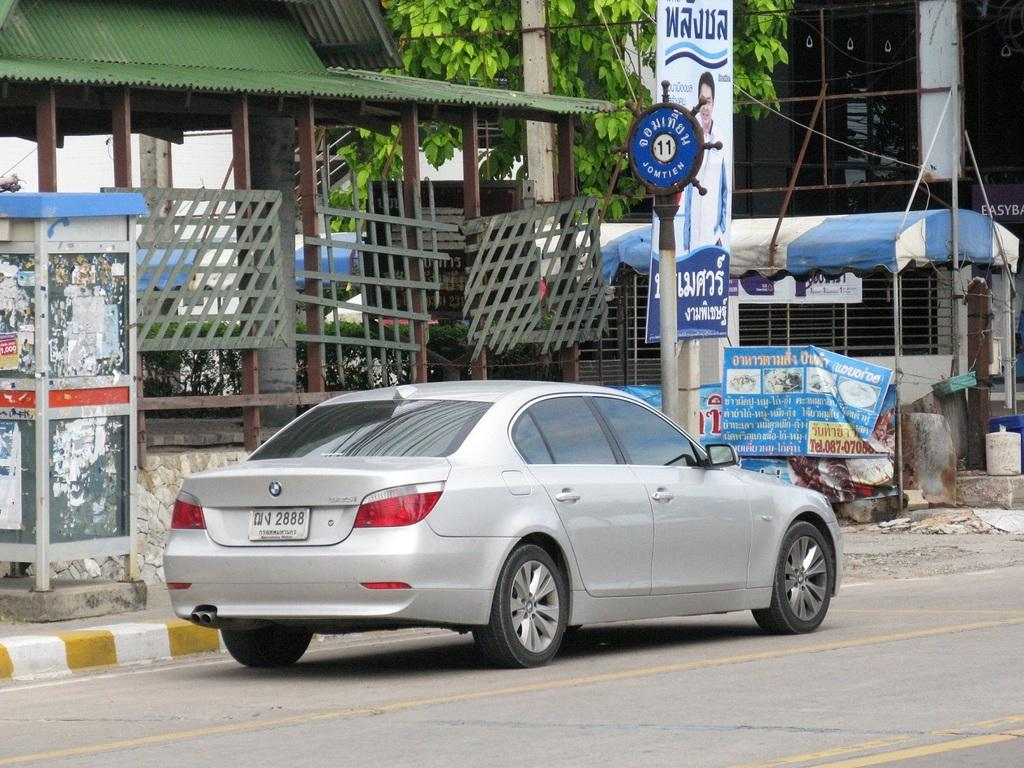What is parked on the road in the image? There is a car parked on the road in the image. What can be seen in the background of the image? There are buildings, trees, and a sign board in the background of the image. What type of clam is being used to create the sign board in the image? There is no clam present in the image, and the sign board is not made of any clam material. 